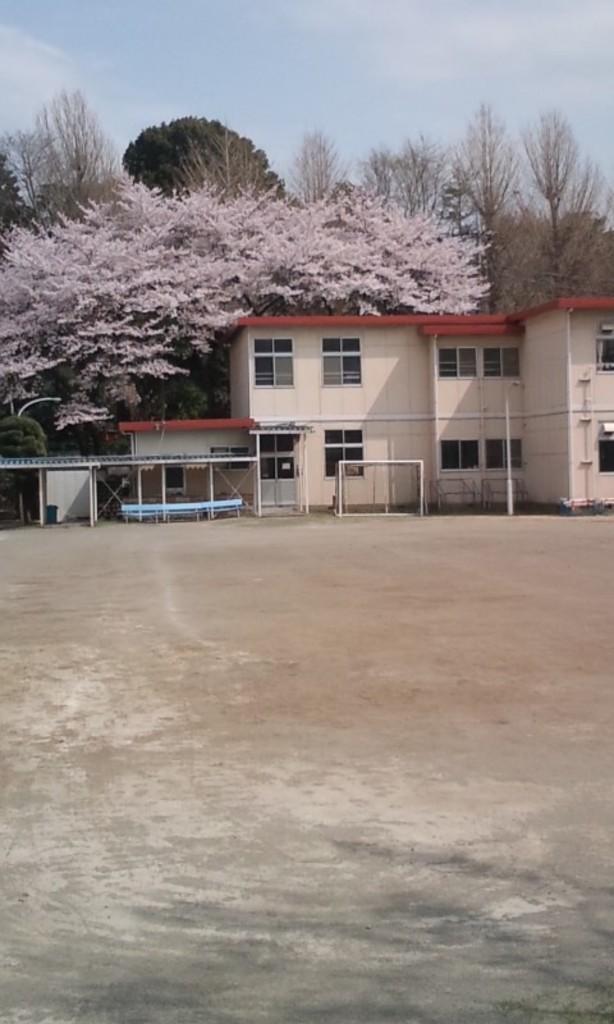Can you describe this image briefly? In this image we can see one building, few objects with poles looks like sheds on the left side of the image, three benches, one object attached to the door, some objects on the ground near the building, some trees in the background and at the top there is the sky. There is a ground in front of the building. 